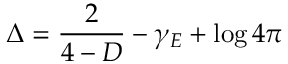Convert formula to latex. <formula><loc_0><loc_0><loc_500><loc_500>\Delta = \frac { 2 } { 4 - D } - \gamma _ { E } + \log 4 \pi</formula> 